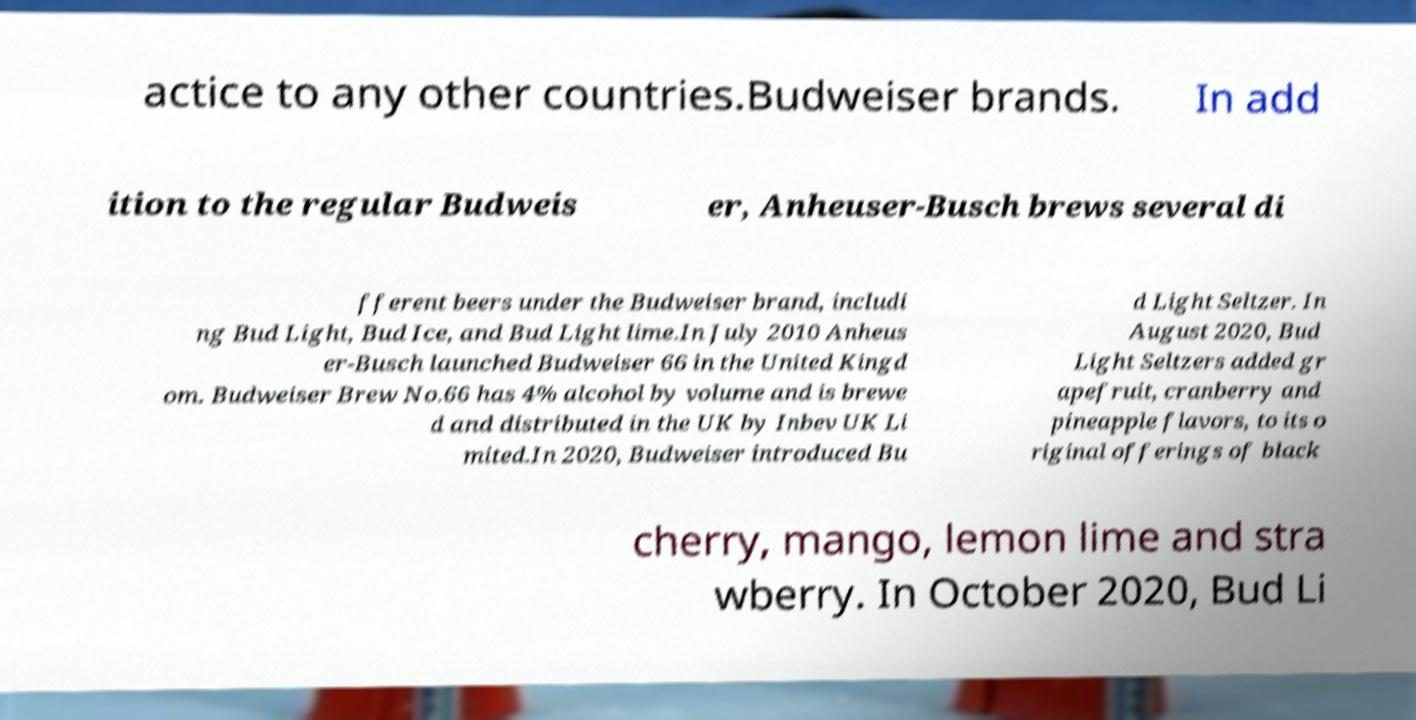There's text embedded in this image that I need extracted. Can you transcribe it verbatim? actice to any other countries.Budweiser brands. In add ition to the regular Budweis er, Anheuser-Busch brews several di fferent beers under the Budweiser brand, includi ng Bud Light, Bud Ice, and Bud Light lime.In July 2010 Anheus er-Busch launched Budweiser 66 in the United Kingd om. Budweiser Brew No.66 has 4% alcohol by volume and is brewe d and distributed in the UK by Inbev UK Li mited.In 2020, Budweiser introduced Bu d Light Seltzer. In August 2020, Bud Light Seltzers added gr apefruit, cranberry and pineapple flavors, to its o riginal offerings of black cherry, mango, lemon lime and stra wberry. In October 2020, Bud Li 